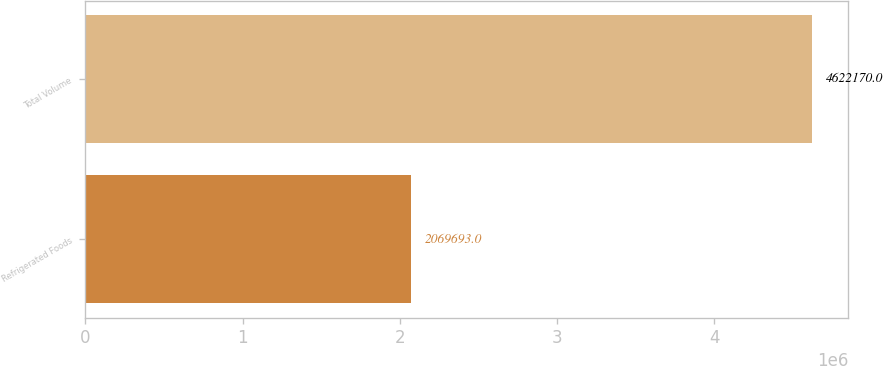Convert chart to OTSL. <chart><loc_0><loc_0><loc_500><loc_500><bar_chart><fcel>Refrigerated Foods<fcel>Total Volume<nl><fcel>2.06969e+06<fcel>4.62217e+06<nl></chart> 